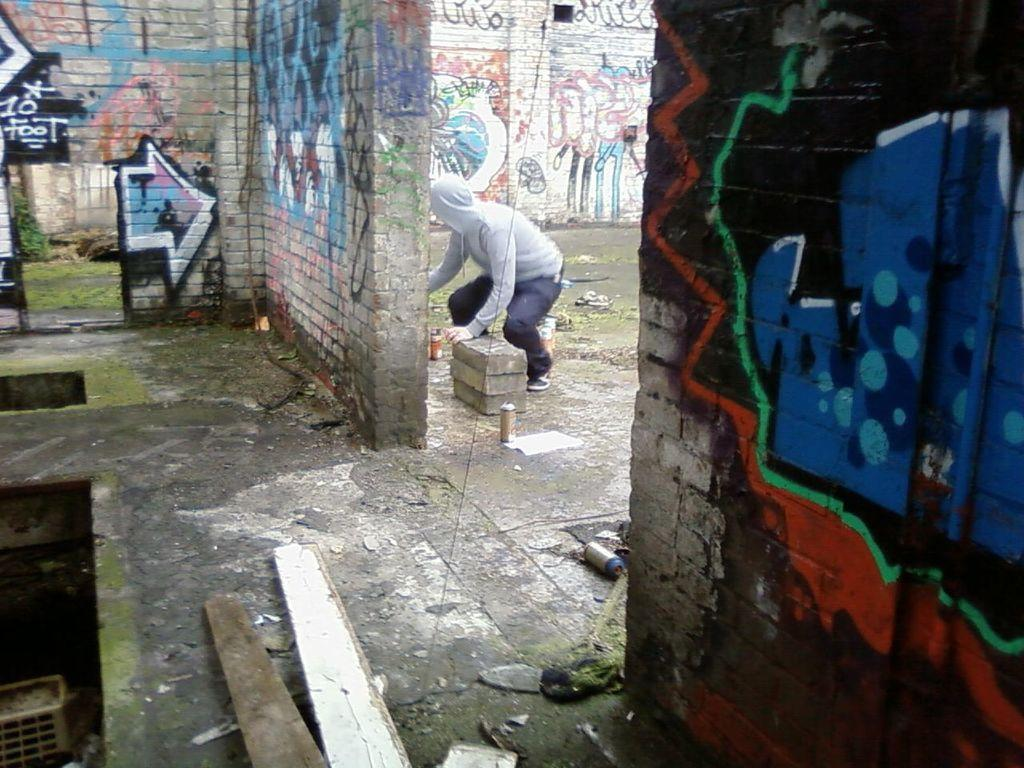Who or what is present in the image? There is a person in the image. What objects can be seen at the bottom of the image? There are wooden blocks at the bottom of the image. What type of building material is visible in the image? There are bricks in the image. What can be seen in the background of the image? There are walls in the background of the image. What is on the walls in the background? There is graffiti on the walls in the background. What type of government is depicted in the graffiti on the walls? There is no indication of a specific government in the graffiti on the walls; it is simply an artistic expression. 